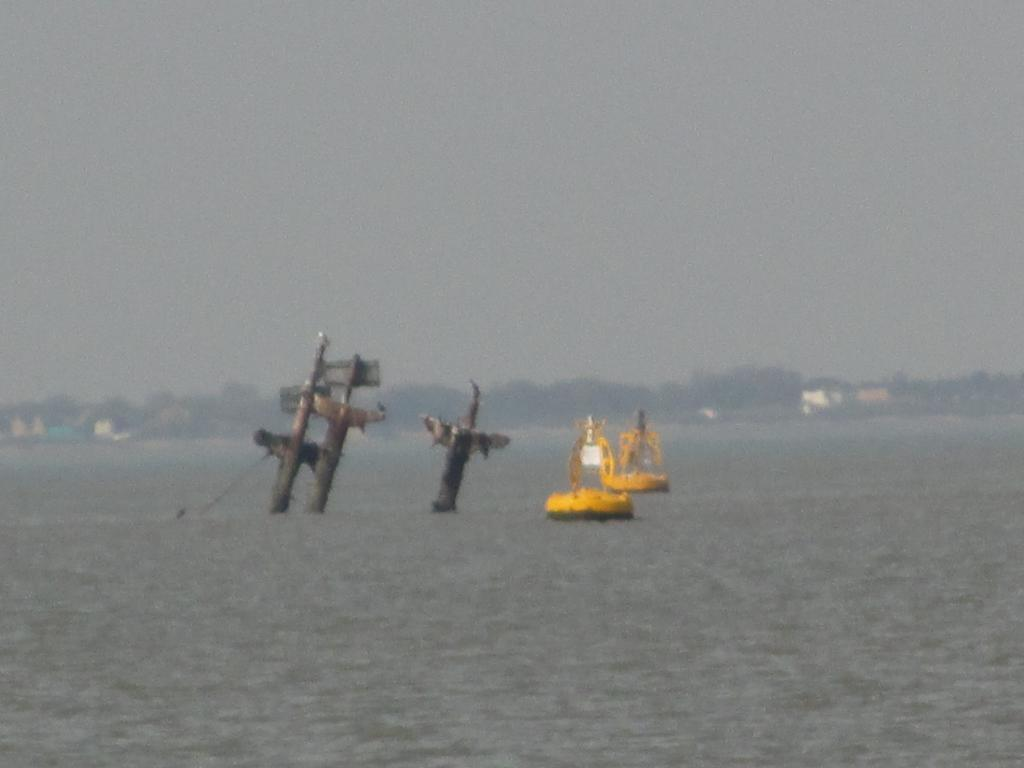What can be seen in the water in the image? There are three poles and two unclear objects in the water. What is visible in the background of the image? There are trees, buildings, and the sky visible in the background of the image. What time is the clock showing in the image? There is no clock present in the image. What story is being told by the objects in the water? The objects in the water do not tell a story, as they are unclear and their nature is not specified. 